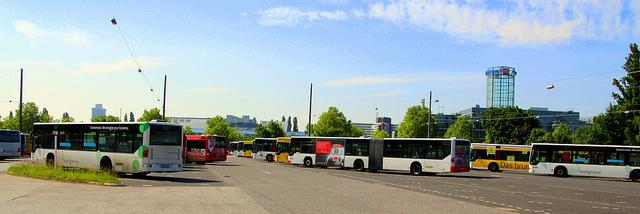What color is the water tower?
Give a very brief answer. Blue. How many poles are there?
Short answer required. 4. What is bordering the highway?
Concise answer only. Trees. Is this a parking lot for bus's?
Short answer required. Yes. 